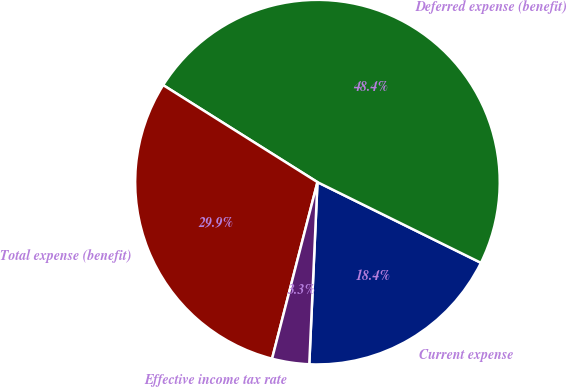Convert chart. <chart><loc_0><loc_0><loc_500><loc_500><pie_chart><fcel>Current expense<fcel>Deferred expense (benefit)<fcel>Total expense (benefit)<fcel>Effective income tax rate<nl><fcel>18.42%<fcel>48.36%<fcel>29.93%<fcel>3.29%<nl></chart> 